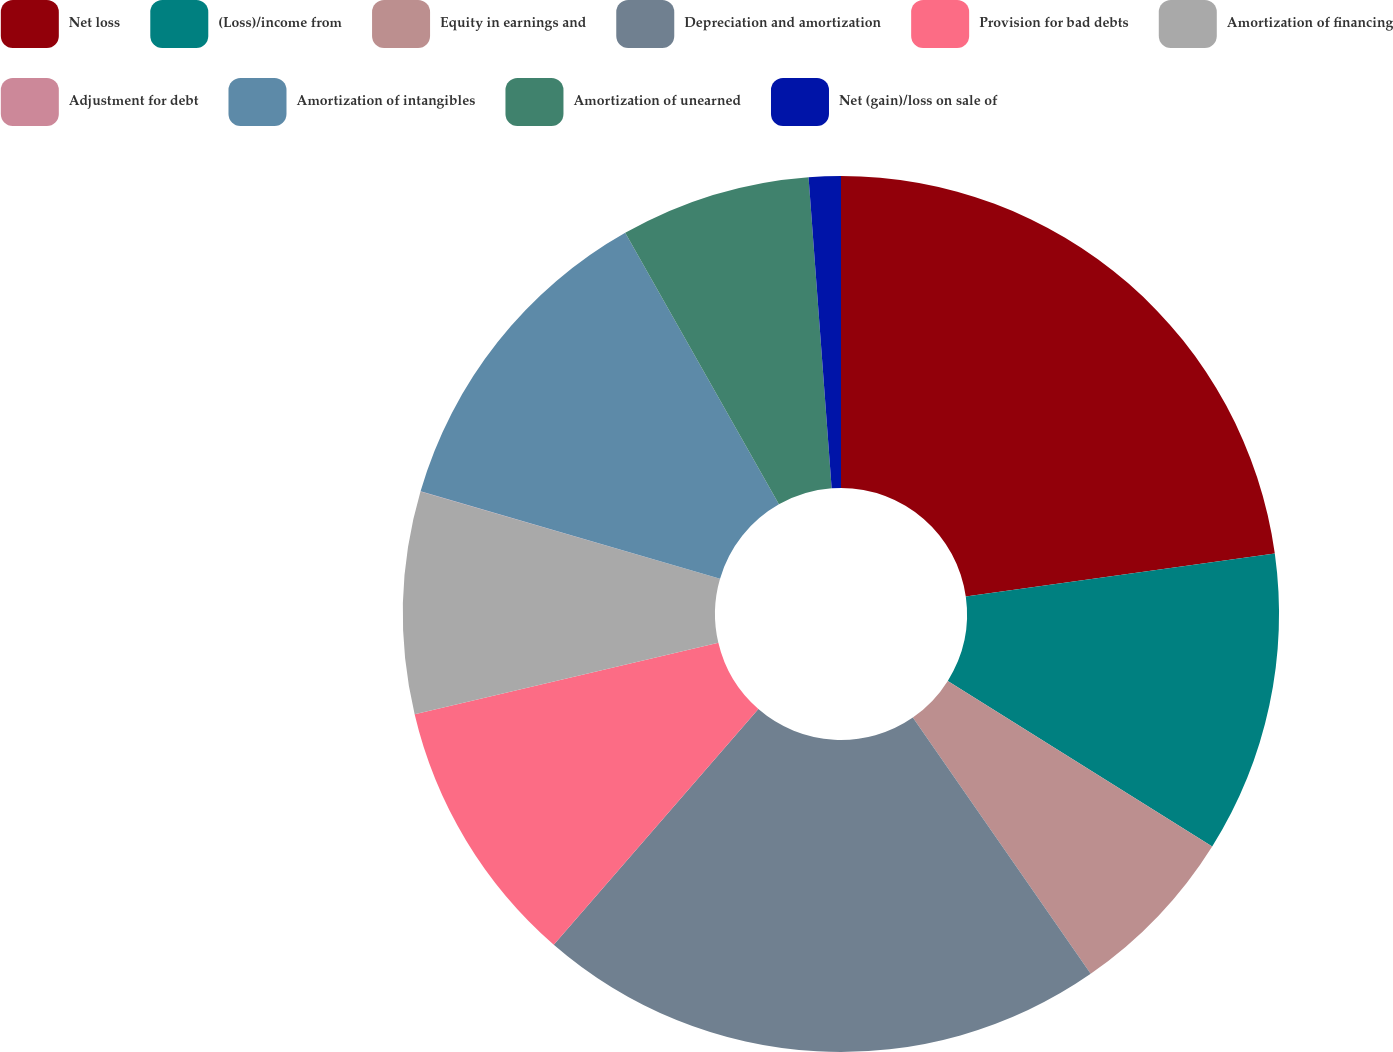Convert chart. <chart><loc_0><loc_0><loc_500><loc_500><pie_chart><fcel>Net loss<fcel>(Loss)/income from<fcel>Equity in earnings and<fcel>Depreciation and amortization<fcel>Provision for bad debts<fcel>Amortization of financing<fcel>Adjustment for debt<fcel>Amortization of intangibles<fcel>Amortization of unearned<fcel>Net (gain)/loss on sale of<nl><fcel>22.8%<fcel>11.11%<fcel>6.44%<fcel>21.04%<fcel>9.94%<fcel>8.19%<fcel>0.01%<fcel>12.28%<fcel>7.02%<fcel>1.18%<nl></chart> 